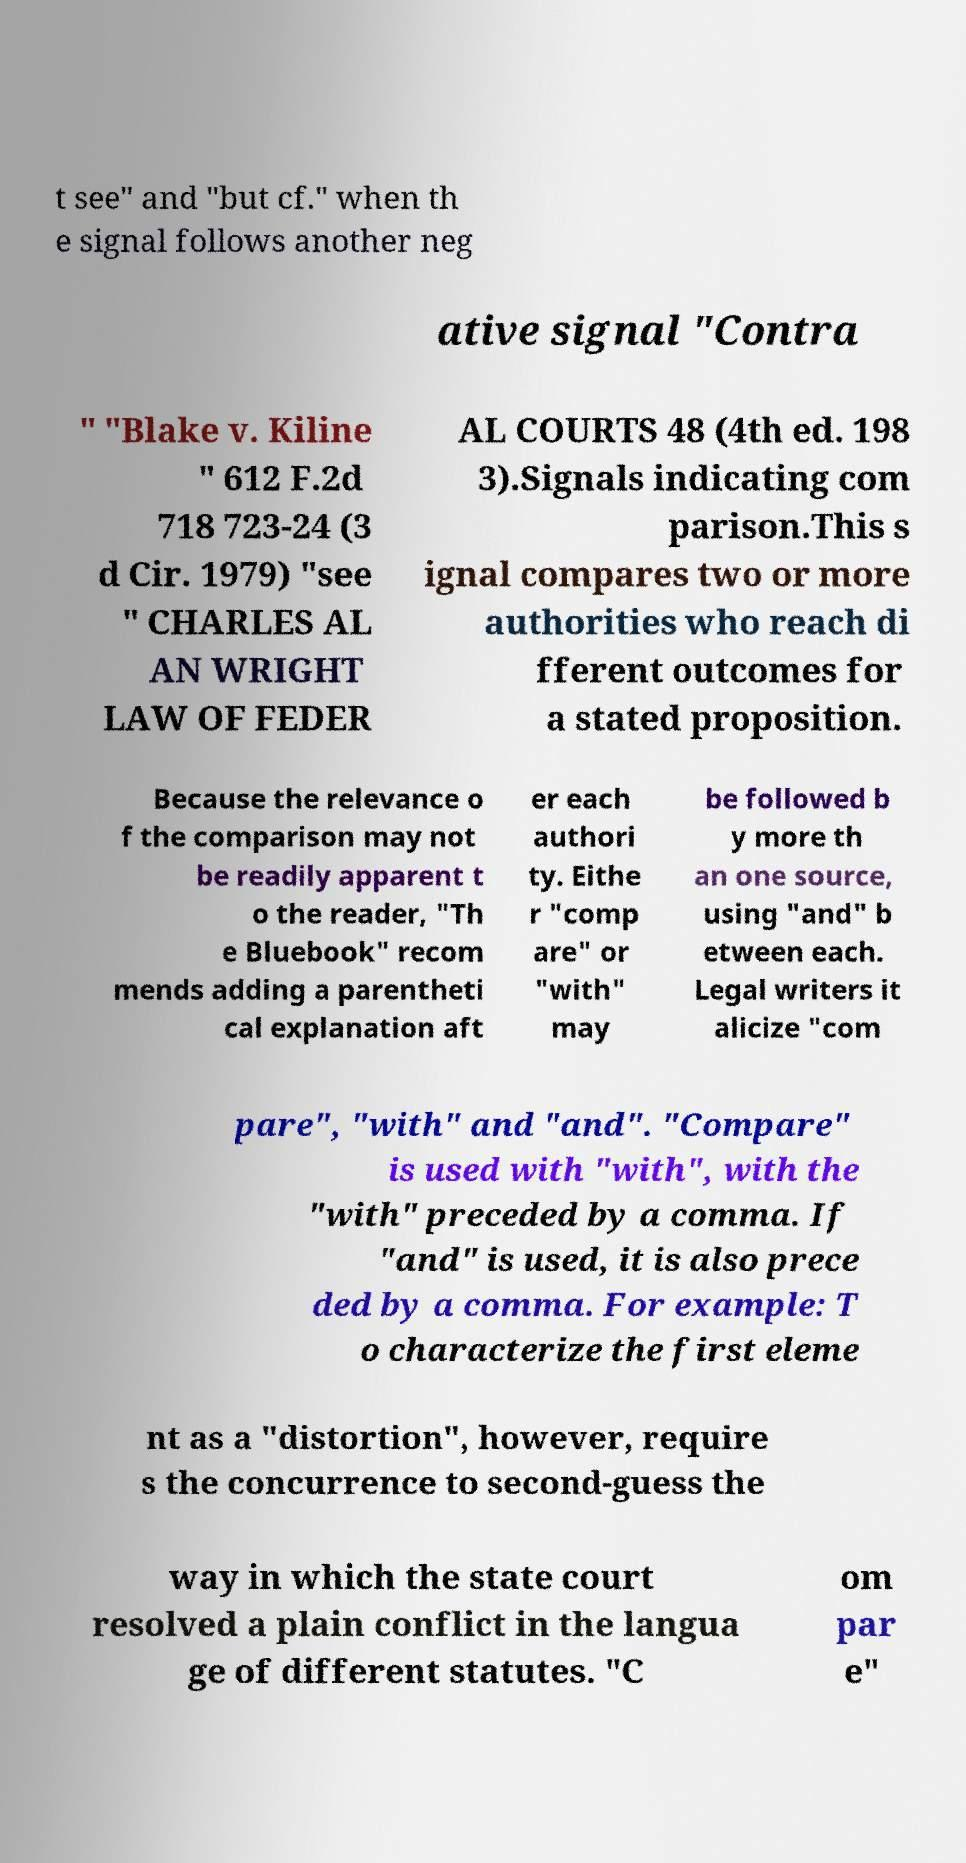There's text embedded in this image that I need extracted. Can you transcribe it verbatim? t see" and "but cf." when th e signal follows another neg ative signal "Contra " "Blake v. Kiline " 612 F.2d 718 723-24 (3 d Cir. 1979) "see " CHARLES AL AN WRIGHT LAW OF FEDER AL COURTS 48 (4th ed. 198 3).Signals indicating com parison.This s ignal compares two or more authorities who reach di fferent outcomes for a stated proposition. Because the relevance o f the comparison may not be readily apparent t o the reader, "Th e Bluebook" recom mends adding a parentheti cal explanation aft er each authori ty. Eithe r "comp are" or "with" may be followed b y more th an one source, using "and" b etween each. Legal writers it alicize "com pare", "with" and "and". "Compare" is used with "with", with the "with" preceded by a comma. If "and" is used, it is also prece ded by a comma. For example: T o characterize the first eleme nt as a "distortion", however, require s the concurrence to second-guess the way in which the state court resolved a plain conflict in the langua ge of different statutes. "C om par e" 